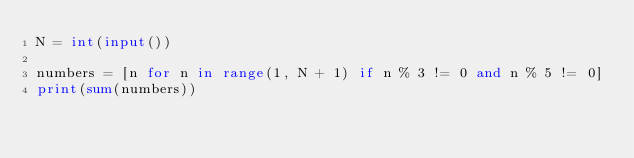<code> <loc_0><loc_0><loc_500><loc_500><_Python_>N = int(input())

numbers = [n for n in range(1, N + 1) if n % 3 != 0 and n % 5 != 0]
print(sum(numbers))

</code> 